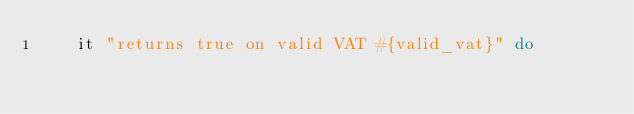Convert code to text. <code><loc_0><loc_0><loc_500><loc_500><_Ruby_>    it "returns true on valid VAT #{valid_vat}" do</code> 